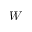Convert formula to latex. <formula><loc_0><loc_0><loc_500><loc_500>W</formula> 